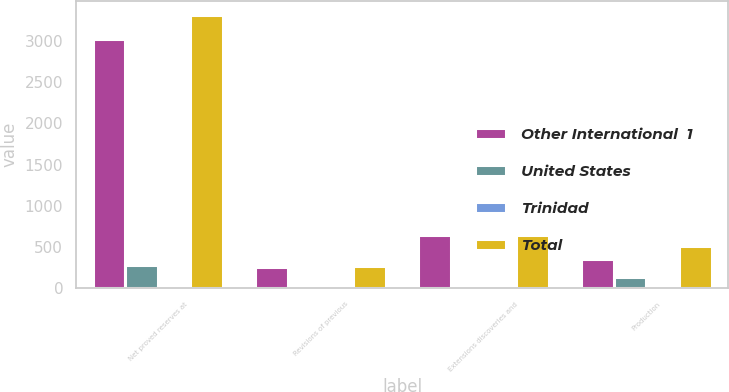Convert chart to OTSL. <chart><loc_0><loc_0><loc_500><loc_500><stacked_bar_chart><ecel><fcel>Net proved reserves at<fcel>Revisions of previous<fcel>Extensions discoveries and<fcel>Production<nl><fcel>Other International  1<fcel>3021.2<fcel>252.2<fcel>638.3<fcel>348.4<nl><fcel>United States<fcel>280.9<fcel>12.9<fcel>4.5<fcel>132.5<nl><fcel>Trinidad<fcel>15.8<fcel>5.5<fcel>4.7<fcel>25.4<nl><fcel>Total<fcel>3317.9<fcel>270.6<fcel>647.5<fcel>506.3<nl></chart> 